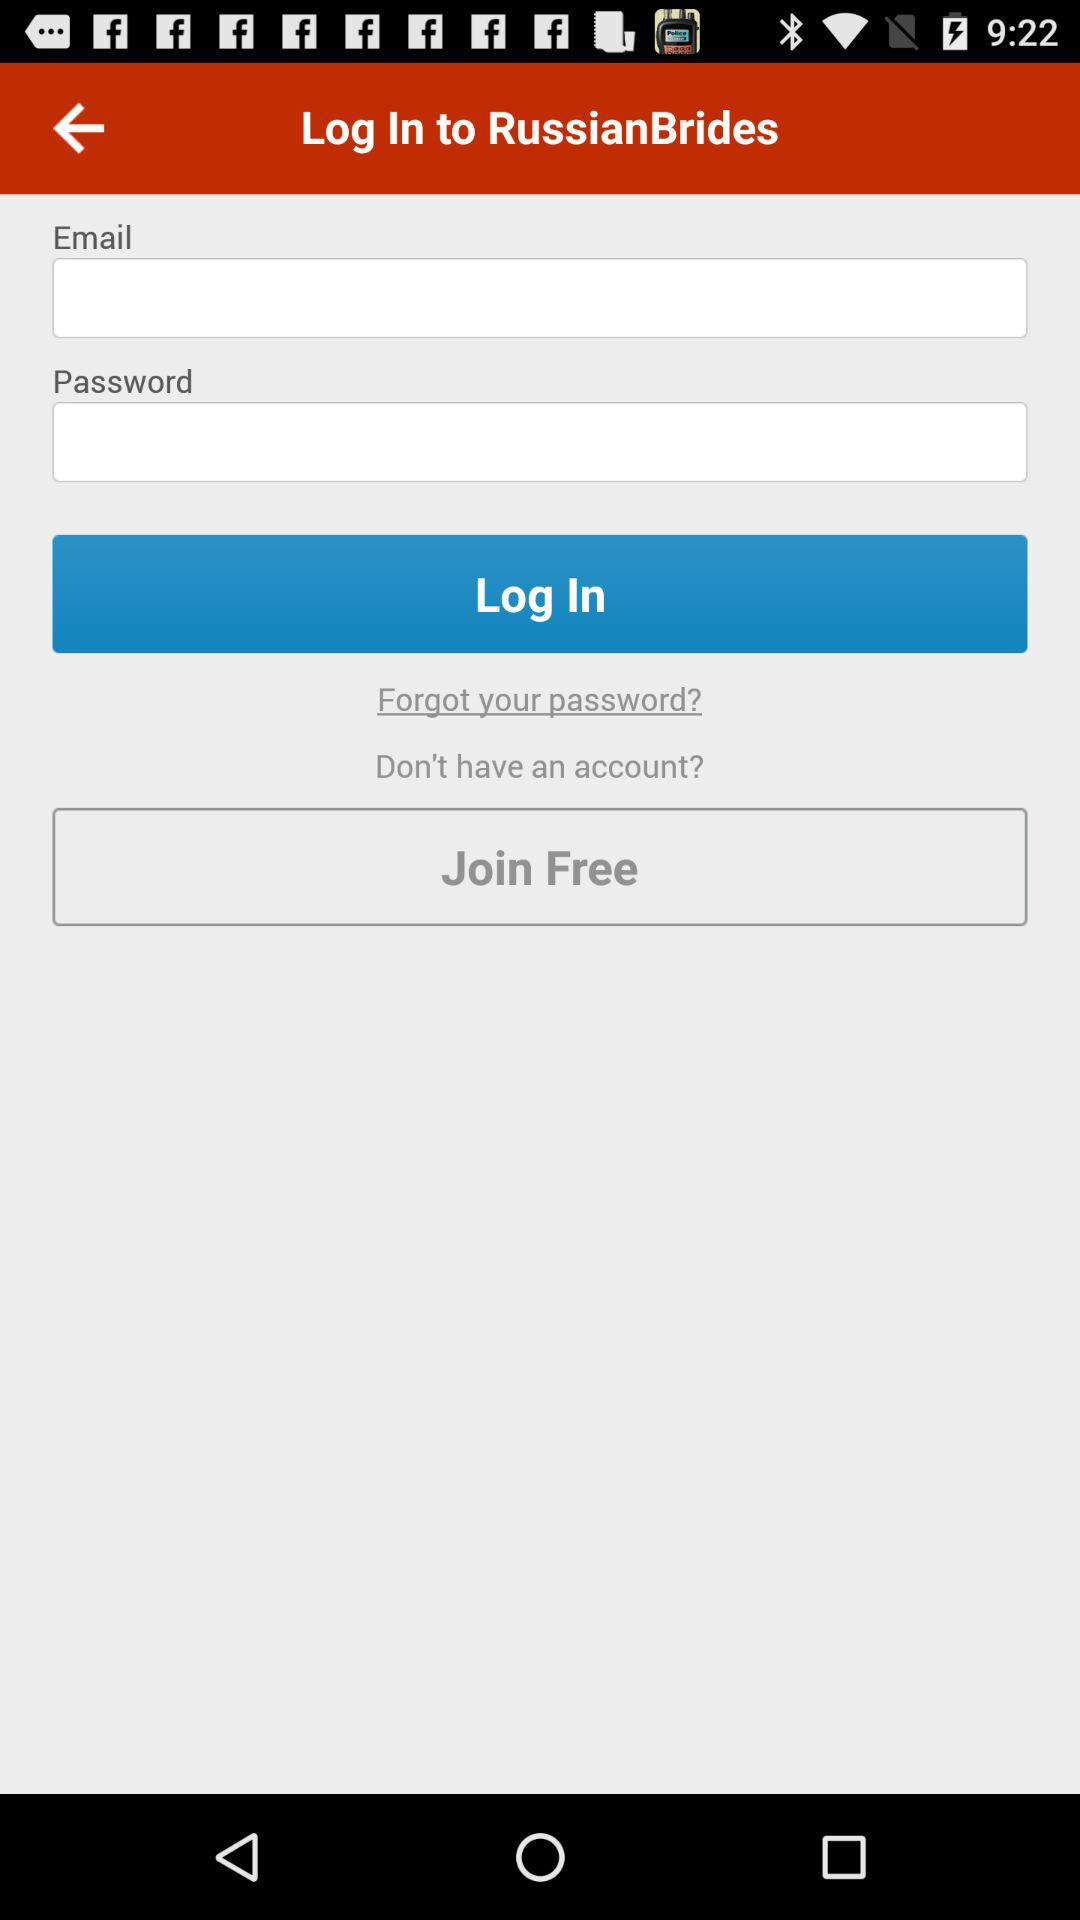Can we reset password?
When the provided information is insufficient, respond with <no answer>. <no answer> 